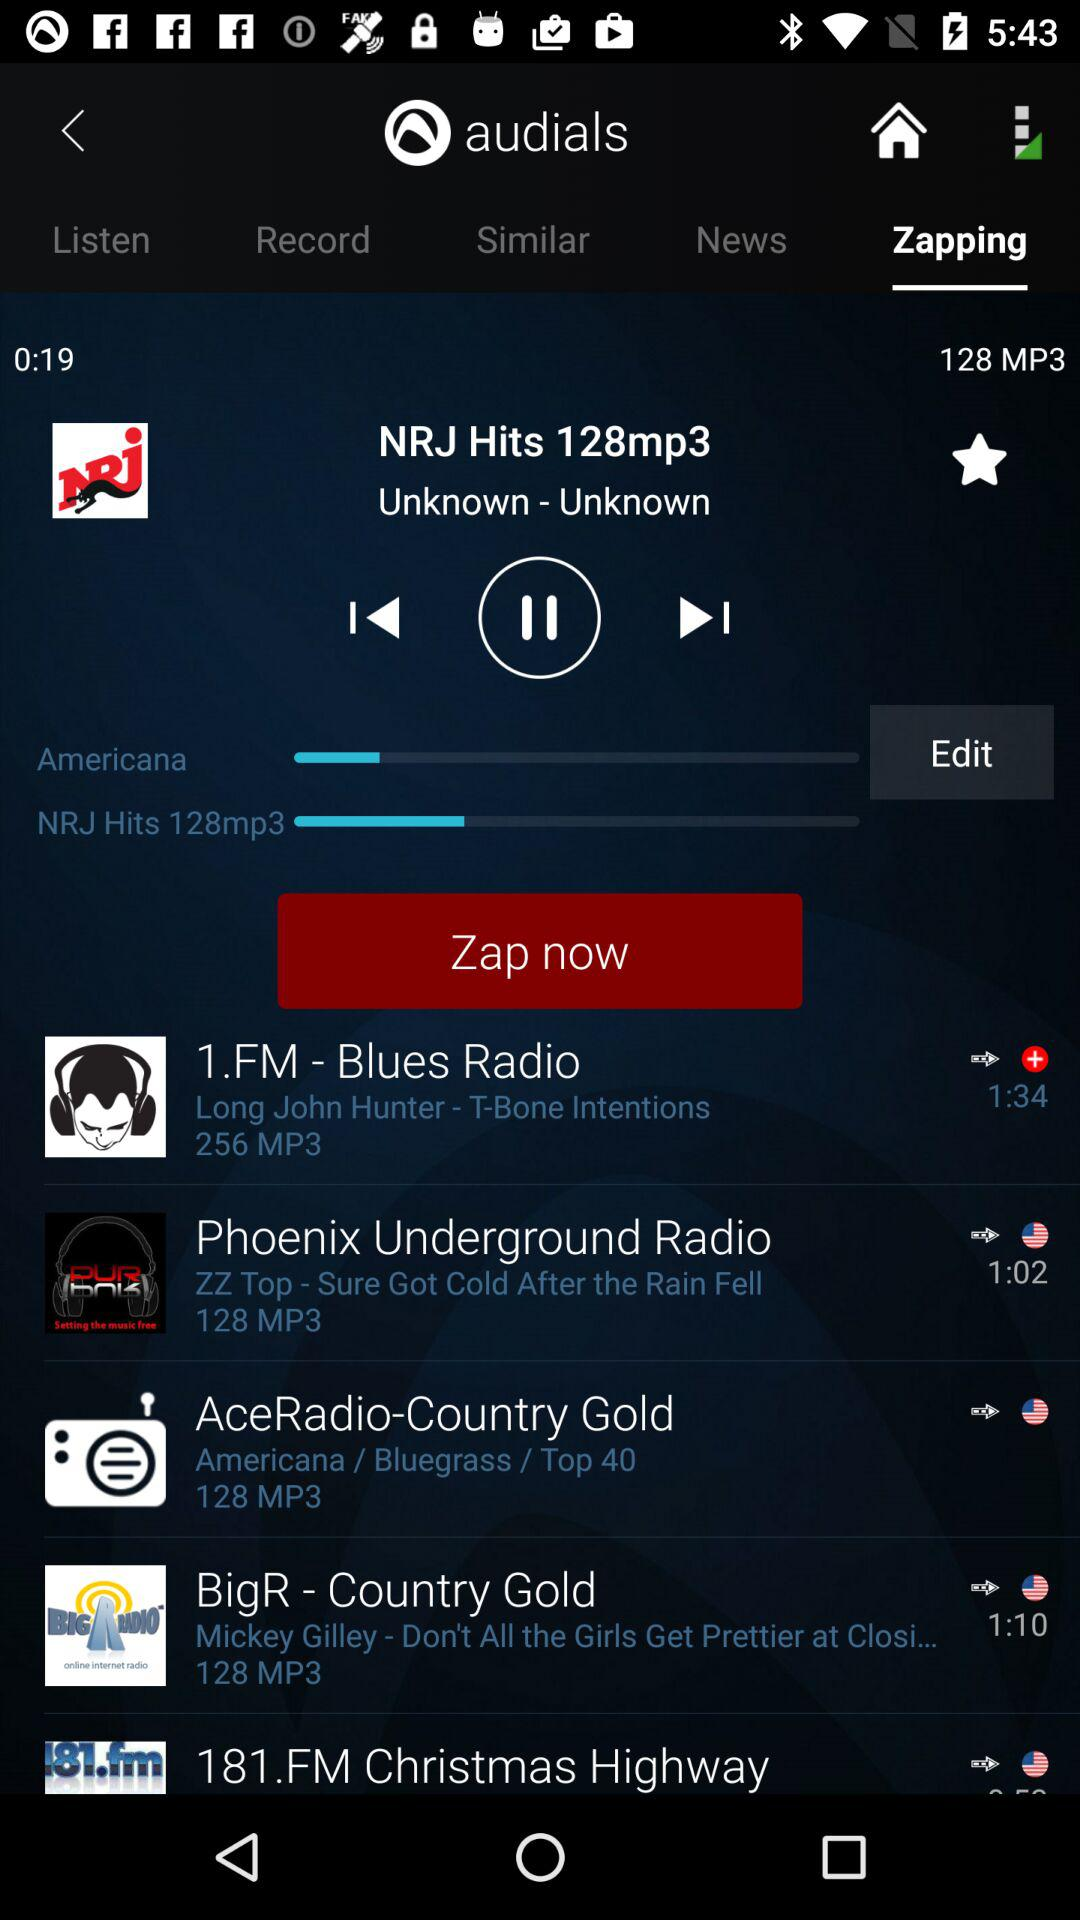What is the name of the application? The name of the application is "audials". 